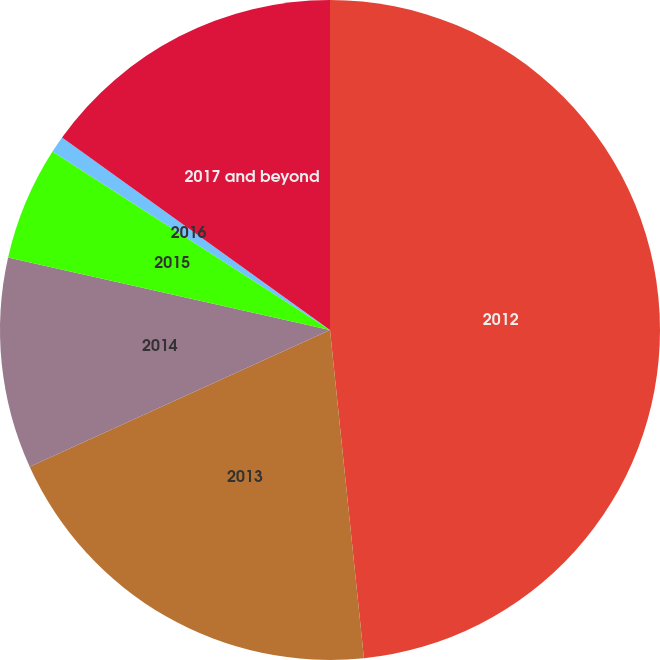<chart> <loc_0><loc_0><loc_500><loc_500><pie_chart><fcel>2012<fcel>2013<fcel>2014<fcel>2015<fcel>2016<fcel>2017 and beyond<nl><fcel>48.36%<fcel>19.84%<fcel>10.33%<fcel>5.57%<fcel>0.82%<fcel>15.08%<nl></chart> 